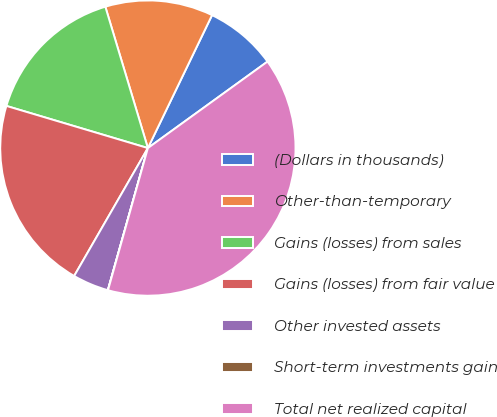<chart> <loc_0><loc_0><loc_500><loc_500><pie_chart><fcel>(Dollars in thousands)<fcel>Other-than-temporary<fcel>Gains (losses) from sales<fcel>Gains (losses) from fair value<fcel>Other invested assets<fcel>Short-term investments gain<fcel>Total net realized capital<nl><fcel>7.88%<fcel>11.81%<fcel>15.74%<fcel>21.29%<fcel>3.95%<fcel>0.02%<fcel>39.32%<nl></chart> 